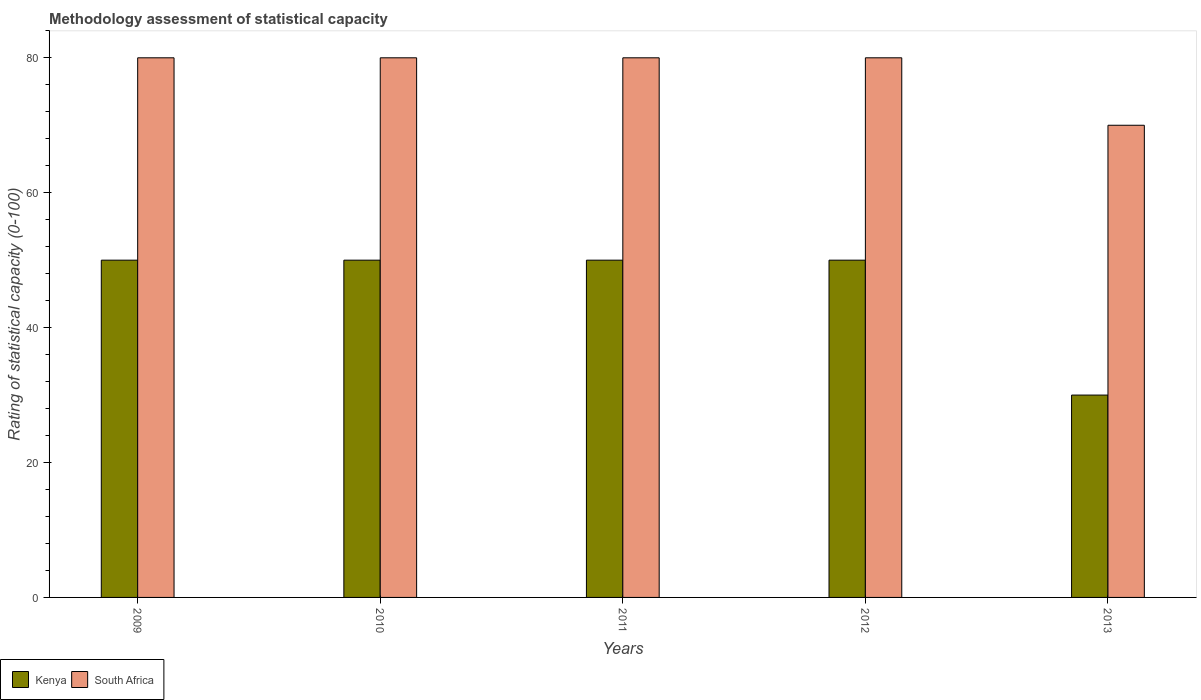Are the number of bars per tick equal to the number of legend labels?
Offer a terse response. Yes. What is the label of the 5th group of bars from the left?
Offer a very short reply. 2013. In how many cases, is the number of bars for a given year not equal to the number of legend labels?
Provide a short and direct response. 0. What is the rating of statistical capacity in Kenya in 2009?
Provide a short and direct response. 50. Across all years, what is the maximum rating of statistical capacity in South Africa?
Offer a terse response. 80. Across all years, what is the minimum rating of statistical capacity in South Africa?
Provide a succinct answer. 70. In which year was the rating of statistical capacity in Kenya minimum?
Offer a terse response. 2013. What is the total rating of statistical capacity in South Africa in the graph?
Provide a short and direct response. 390. What is the difference between the rating of statistical capacity in South Africa in 2009 and that in 2012?
Your answer should be very brief. 0. What is the difference between the rating of statistical capacity in South Africa in 2009 and the rating of statistical capacity in Kenya in 2012?
Give a very brief answer. 30. In the year 2011, what is the difference between the rating of statistical capacity in Kenya and rating of statistical capacity in South Africa?
Offer a very short reply. -30. What is the ratio of the rating of statistical capacity in South Africa in 2010 to that in 2013?
Provide a short and direct response. 1.14. Is the rating of statistical capacity in South Africa in 2009 less than that in 2013?
Provide a short and direct response. No. Is the difference between the rating of statistical capacity in Kenya in 2009 and 2013 greater than the difference between the rating of statistical capacity in South Africa in 2009 and 2013?
Provide a succinct answer. Yes. What is the difference between the highest and the lowest rating of statistical capacity in South Africa?
Ensure brevity in your answer.  10. What does the 2nd bar from the left in 2009 represents?
Offer a very short reply. South Africa. What does the 2nd bar from the right in 2013 represents?
Make the answer very short. Kenya. How many years are there in the graph?
Your response must be concise. 5. What is the difference between two consecutive major ticks on the Y-axis?
Your answer should be very brief. 20. Are the values on the major ticks of Y-axis written in scientific E-notation?
Offer a very short reply. No. Does the graph contain any zero values?
Provide a short and direct response. No. Where does the legend appear in the graph?
Offer a terse response. Bottom left. How are the legend labels stacked?
Provide a succinct answer. Horizontal. What is the title of the graph?
Your answer should be compact. Methodology assessment of statistical capacity. What is the label or title of the X-axis?
Make the answer very short. Years. What is the label or title of the Y-axis?
Offer a terse response. Rating of statistical capacity (0-100). What is the Rating of statistical capacity (0-100) of Kenya in 2013?
Your answer should be very brief. 30. Across all years, what is the maximum Rating of statistical capacity (0-100) of Kenya?
Your answer should be very brief. 50. Across all years, what is the maximum Rating of statistical capacity (0-100) of South Africa?
Ensure brevity in your answer.  80. Across all years, what is the minimum Rating of statistical capacity (0-100) of Kenya?
Keep it short and to the point. 30. What is the total Rating of statistical capacity (0-100) of Kenya in the graph?
Your answer should be very brief. 230. What is the total Rating of statistical capacity (0-100) of South Africa in the graph?
Keep it short and to the point. 390. What is the difference between the Rating of statistical capacity (0-100) in Kenya in 2009 and that in 2010?
Your response must be concise. 0. What is the difference between the Rating of statistical capacity (0-100) of South Africa in 2009 and that in 2011?
Your answer should be very brief. 0. What is the difference between the Rating of statistical capacity (0-100) of South Africa in 2009 and that in 2012?
Keep it short and to the point. 0. What is the difference between the Rating of statistical capacity (0-100) in Kenya in 2010 and that in 2011?
Ensure brevity in your answer.  0. What is the difference between the Rating of statistical capacity (0-100) in South Africa in 2010 and that in 2011?
Your answer should be very brief. 0. What is the difference between the Rating of statistical capacity (0-100) in Kenya in 2010 and that in 2012?
Offer a very short reply. 0. What is the difference between the Rating of statistical capacity (0-100) in Kenya in 2010 and that in 2013?
Your response must be concise. 20. What is the difference between the Rating of statistical capacity (0-100) of South Africa in 2010 and that in 2013?
Offer a terse response. 10. What is the difference between the Rating of statistical capacity (0-100) of Kenya in 2011 and that in 2012?
Provide a short and direct response. 0. What is the difference between the Rating of statistical capacity (0-100) of South Africa in 2011 and that in 2012?
Your response must be concise. 0. What is the difference between the Rating of statistical capacity (0-100) of South Africa in 2011 and that in 2013?
Provide a succinct answer. 10. What is the difference between the Rating of statistical capacity (0-100) in Kenya in 2009 and the Rating of statistical capacity (0-100) in South Africa in 2010?
Provide a short and direct response. -30. What is the difference between the Rating of statistical capacity (0-100) in Kenya in 2009 and the Rating of statistical capacity (0-100) in South Africa in 2012?
Your answer should be very brief. -30. What is the difference between the Rating of statistical capacity (0-100) in Kenya in 2009 and the Rating of statistical capacity (0-100) in South Africa in 2013?
Give a very brief answer. -20. What is the difference between the Rating of statistical capacity (0-100) of Kenya in 2010 and the Rating of statistical capacity (0-100) of South Africa in 2013?
Give a very brief answer. -20. What is the difference between the Rating of statistical capacity (0-100) in Kenya in 2011 and the Rating of statistical capacity (0-100) in South Africa in 2012?
Provide a succinct answer. -30. What is the average Rating of statistical capacity (0-100) in South Africa per year?
Your answer should be very brief. 78. In the year 2009, what is the difference between the Rating of statistical capacity (0-100) of Kenya and Rating of statistical capacity (0-100) of South Africa?
Offer a very short reply. -30. In the year 2010, what is the difference between the Rating of statistical capacity (0-100) in Kenya and Rating of statistical capacity (0-100) in South Africa?
Your response must be concise. -30. In the year 2011, what is the difference between the Rating of statistical capacity (0-100) of Kenya and Rating of statistical capacity (0-100) of South Africa?
Your response must be concise. -30. In the year 2012, what is the difference between the Rating of statistical capacity (0-100) of Kenya and Rating of statistical capacity (0-100) of South Africa?
Provide a short and direct response. -30. In the year 2013, what is the difference between the Rating of statistical capacity (0-100) of Kenya and Rating of statistical capacity (0-100) of South Africa?
Provide a succinct answer. -40. What is the ratio of the Rating of statistical capacity (0-100) in South Africa in 2009 to that in 2010?
Offer a very short reply. 1. What is the ratio of the Rating of statistical capacity (0-100) in South Africa in 2009 to that in 2011?
Your response must be concise. 1. What is the ratio of the Rating of statistical capacity (0-100) of Kenya in 2010 to that in 2011?
Make the answer very short. 1. What is the ratio of the Rating of statistical capacity (0-100) in Kenya in 2010 to that in 2013?
Provide a succinct answer. 1.67. What is the ratio of the Rating of statistical capacity (0-100) of South Africa in 2011 to that in 2012?
Ensure brevity in your answer.  1. What is the ratio of the Rating of statistical capacity (0-100) in Kenya in 2011 to that in 2013?
Make the answer very short. 1.67. What is the ratio of the Rating of statistical capacity (0-100) in Kenya in 2012 to that in 2013?
Give a very brief answer. 1.67. What is the difference between the highest and the second highest Rating of statistical capacity (0-100) in Kenya?
Make the answer very short. 0. What is the difference between the highest and the lowest Rating of statistical capacity (0-100) of Kenya?
Your answer should be very brief. 20. What is the difference between the highest and the lowest Rating of statistical capacity (0-100) in South Africa?
Your response must be concise. 10. 